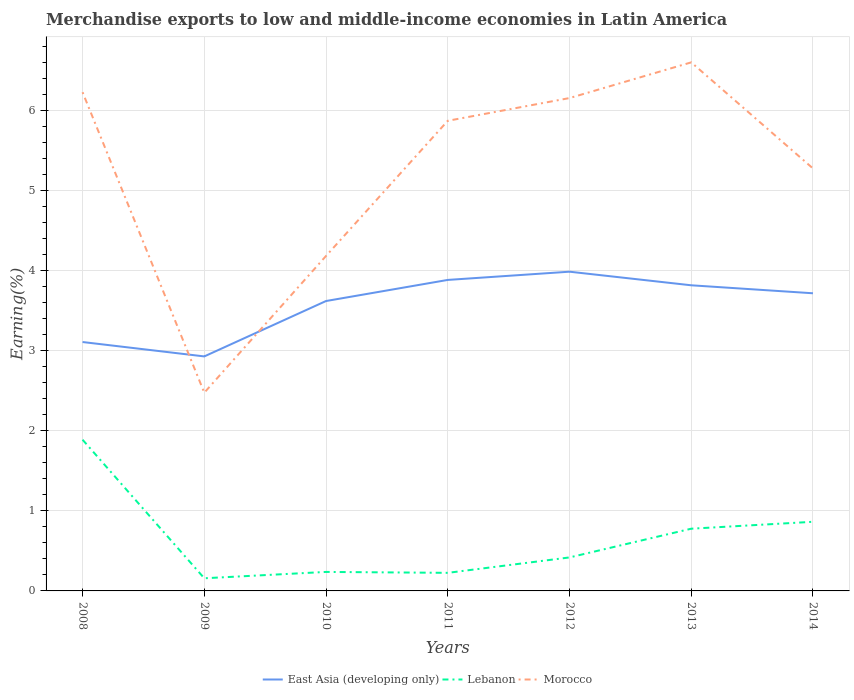Is the number of lines equal to the number of legend labels?
Your answer should be very brief. Yes. Across all years, what is the maximum percentage of amount earned from merchandise exports in Lebanon?
Ensure brevity in your answer.  0.16. In which year was the percentage of amount earned from merchandise exports in East Asia (developing only) maximum?
Your answer should be very brief. 2009. What is the total percentage of amount earned from merchandise exports in Morocco in the graph?
Offer a terse response. -1.09. What is the difference between the highest and the second highest percentage of amount earned from merchandise exports in Morocco?
Ensure brevity in your answer.  4.12. What is the difference between the highest and the lowest percentage of amount earned from merchandise exports in Lebanon?
Provide a succinct answer. 3. How many years are there in the graph?
Offer a very short reply. 7. What is the difference between two consecutive major ticks on the Y-axis?
Offer a terse response. 1. Does the graph contain grids?
Your response must be concise. Yes. Where does the legend appear in the graph?
Provide a short and direct response. Bottom center. How are the legend labels stacked?
Your answer should be compact. Horizontal. What is the title of the graph?
Offer a very short reply. Merchandise exports to low and middle-income economies in Latin America. Does "Latvia" appear as one of the legend labels in the graph?
Provide a short and direct response. No. What is the label or title of the Y-axis?
Your answer should be very brief. Earning(%). What is the Earning(%) in East Asia (developing only) in 2008?
Offer a terse response. 3.11. What is the Earning(%) of Lebanon in 2008?
Provide a succinct answer. 1.89. What is the Earning(%) of Morocco in 2008?
Provide a short and direct response. 6.23. What is the Earning(%) of East Asia (developing only) in 2009?
Offer a terse response. 2.93. What is the Earning(%) in Lebanon in 2009?
Make the answer very short. 0.16. What is the Earning(%) of Morocco in 2009?
Keep it short and to the point. 2.48. What is the Earning(%) in East Asia (developing only) in 2010?
Make the answer very short. 3.62. What is the Earning(%) in Lebanon in 2010?
Offer a terse response. 0.24. What is the Earning(%) in Morocco in 2010?
Your answer should be compact. 4.18. What is the Earning(%) of East Asia (developing only) in 2011?
Your answer should be very brief. 3.88. What is the Earning(%) in Lebanon in 2011?
Offer a very short reply. 0.23. What is the Earning(%) of Morocco in 2011?
Provide a short and direct response. 5.87. What is the Earning(%) of East Asia (developing only) in 2012?
Your response must be concise. 3.99. What is the Earning(%) in Lebanon in 2012?
Keep it short and to the point. 0.42. What is the Earning(%) in Morocco in 2012?
Provide a succinct answer. 6.15. What is the Earning(%) of East Asia (developing only) in 2013?
Ensure brevity in your answer.  3.82. What is the Earning(%) of Lebanon in 2013?
Offer a very short reply. 0.78. What is the Earning(%) in Morocco in 2013?
Provide a short and direct response. 6.6. What is the Earning(%) of East Asia (developing only) in 2014?
Your response must be concise. 3.72. What is the Earning(%) of Lebanon in 2014?
Ensure brevity in your answer.  0.86. What is the Earning(%) of Morocco in 2014?
Your answer should be very brief. 5.27. Across all years, what is the maximum Earning(%) of East Asia (developing only)?
Your answer should be compact. 3.99. Across all years, what is the maximum Earning(%) in Lebanon?
Provide a succinct answer. 1.89. Across all years, what is the maximum Earning(%) of Morocco?
Make the answer very short. 6.6. Across all years, what is the minimum Earning(%) in East Asia (developing only)?
Give a very brief answer. 2.93. Across all years, what is the minimum Earning(%) of Lebanon?
Provide a short and direct response. 0.16. Across all years, what is the minimum Earning(%) of Morocco?
Ensure brevity in your answer.  2.48. What is the total Earning(%) in East Asia (developing only) in the graph?
Give a very brief answer. 25.06. What is the total Earning(%) of Lebanon in the graph?
Offer a very short reply. 4.57. What is the total Earning(%) of Morocco in the graph?
Provide a short and direct response. 36.78. What is the difference between the Earning(%) in East Asia (developing only) in 2008 and that in 2009?
Keep it short and to the point. 0.18. What is the difference between the Earning(%) of Lebanon in 2008 and that in 2009?
Your answer should be very brief. 1.73. What is the difference between the Earning(%) in Morocco in 2008 and that in 2009?
Your answer should be compact. 3.75. What is the difference between the Earning(%) in East Asia (developing only) in 2008 and that in 2010?
Keep it short and to the point. -0.51. What is the difference between the Earning(%) of Lebanon in 2008 and that in 2010?
Offer a terse response. 1.65. What is the difference between the Earning(%) of Morocco in 2008 and that in 2010?
Offer a terse response. 2.04. What is the difference between the Earning(%) of East Asia (developing only) in 2008 and that in 2011?
Your response must be concise. -0.78. What is the difference between the Earning(%) of Lebanon in 2008 and that in 2011?
Offer a very short reply. 1.66. What is the difference between the Earning(%) in Morocco in 2008 and that in 2011?
Your answer should be very brief. 0.36. What is the difference between the Earning(%) in East Asia (developing only) in 2008 and that in 2012?
Ensure brevity in your answer.  -0.88. What is the difference between the Earning(%) of Lebanon in 2008 and that in 2012?
Your answer should be very brief. 1.47. What is the difference between the Earning(%) in Morocco in 2008 and that in 2012?
Give a very brief answer. 0.07. What is the difference between the Earning(%) in East Asia (developing only) in 2008 and that in 2013?
Make the answer very short. -0.71. What is the difference between the Earning(%) of Lebanon in 2008 and that in 2013?
Provide a short and direct response. 1.11. What is the difference between the Earning(%) in Morocco in 2008 and that in 2013?
Provide a short and direct response. -0.37. What is the difference between the Earning(%) in East Asia (developing only) in 2008 and that in 2014?
Keep it short and to the point. -0.61. What is the difference between the Earning(%) in Lebanon in 2008 and that in 2014?
Provide a short and direct response. 1.02. What is the difference between the Earning(%) of East Asia (developing only) in 2009 and that in 2010?
Keep it short and to the point. -0.69. What is the difference between the Earning(%) in Lebanon in 2009 and that in 2010?
Offer a very short reply. -0.08. What is the difference between the Earning(%) in Morocco in 2009 and that in 2010?
Keep it short and to the point. -1.71. What is the difference between the Earning(%) in East Asia (developing only) in 2009 and that in 2011?
Your answer should be compact. -0.95. What is the difference between the Earning(%) in Lebanon in 2009 and that in 2011?
Your answer should be very brief. -0.07. What is the difference between the Earning(%) of Morocco in 2009 and that in 2011?
Your response must be concise. -3.39. What is the difference between the Earning(%) of East Asia (developing only) in 2009 and that in 2012?
Your response must be concise. -1.06. What is the difference between the Earning(%) in Lebanon in 2009 and that in 2012?
Offer a very short reply. -0.26. What is the difference between the Earning(%) in Morocco in 2009 and that in 2012?
Offer a very short reply. -3.68. What is the difference between the Earning(%) in East Asia (developing only) in 2009 and that in 2013?
Ensure brevity in your answer.  -0.89. What is the difference between the Earning(%) in Lebanon in 2009 and that in 2013?
Offer a very short reply. -0.62. What is the difference between the Earning(%) in Morocco in 2009 and that in 2013?
Give a very brief answer. -4.12. What is the difference between the Earning(%) of East Asia (developing only) in 2009 and that in 2014?
Make the answer very short. -0.79. What is the difference between the Earning(%) of Lebanon in 2009 and that in 2014?
Ensure brevity in your answer.  -0.71. What is the difference between the Earning(%) of Morocco in 2009 and that in 2014?
Your response must be concise. -2.8. What is the difference between the Earning(%) in East Asia (developing only) in 2010 and that in 2011?
Your response must be concise. -0.26. What is the difference between the Earning(%) in Lebanon in 2010 and that in 2011?
Your answer should be compact. 0.01. What is the difference between the Earning(%) of Morocco in 2010 and that in 2011?
Give a very brief answer. -1.69. What is the difference between the Earning(%) of East Asia (developing only) in 2010 and that in 2012?
Ensure brevity in your answer.  -0.37. What is the difference between the Earning(%) of Lebanon in 2010 and that in 2012?
Your answer should be very brief. -0.18. What is the difference between the Earning(%) of Morocco in 2010 and that in 2012?
Your response must be concise. -1.97. What is the difference between the Earning(%) in East Asia (developing only) in 2010 and that in 2013?
Your answer should be compact. -0.2. What is the difference between the Earning(%) of Lebanon in 2010 and that in 2013?
Your answer should be compact. -0.54. What is the difference between the Earning(%) in Morocco in 2010 and that in 2013?
Your answer should be very brief. -2.42. What is the difference between the Earning(%) of East Asia (developing only) in 2010 and that in 2014?
Your answer should be very brief. -0.1. What is the difference between the Earning(%) in Lebanon in 2010 and that in 2014?
Your answer should be very brief. -0.63. What is the difference between the Earning(%) of Morocco in 2010 and that in 2014?
Offer a very short reply. -1.09. What is the difference between the Earning(%) in East Asia (developing only) in 2011 and that in 2012?
Offer a very short reply. -0.1. What is the difference between the Earning(%) of Lebanon in 2011 and that in 2012?
Your response must be concise. -0.19. What is the difference between the Earning(%) in Morocco in 2011 and that in 2012?
Your answer should be very brief. -0.28. What is the difference between the Earning(%) in East Asia (developing only) in 2011 and that in 2013?
Provide a short and direct response. 0.07. What is the difference between the Earning(%) in Lebanon in 2011 and that in 2013?
Give a very brief answer. -0.55. What is the difference between the Earning(%) in Morocco in 2011 and that in 2013?
Your answer should be compact. -0.73. What is the difference between the Earning(%) of East Asia (developing only) in 2011 and that in 2014?
Provide a succinct answer. 0.17. What is the difference between the Earning(%) of Lebanon in 2011 and that in 2014?
Your answer should be very brief. -0.64. What is the difference between the Earning(%) of Morocco in 2011 and that in 2014?
Give a very brief answer. 0.6. What is the difference between the Earning(%) in East Asia (developing only) in 2012 and that in 2013?
Offer a very short reply. 0.17. What is the difference between the Earning(%) in Lebanon in 2012 and that in 2013?
Make the answer very short. -0.36. What is the difference between the Earning(%) in Morocco in 2012 and that in 2013?
Offer a terse response. -0.45. What is the difference between the Earning(%) of East Asia (developing only) in 2012 and that in 2014?
Keep it short and to the point. 0.27. What is the difference between the Earning(%) of Lebanon in 2012 and that in 2014?
Your answer should be very brief. -0.45. What is the difference between the Earning(%) in Morocco in 2012 and that in 2014?
Keep it short and to the point. 0.88. What is the difference between the Earning(%) in East Asia (developing only) in 2013 and that in 2014?
Make the answer very short. 0.1. What is the difference between the Earning(%) in Lebanon in 2013 and that in 2014?
Give a very brief answer. -0.09. What is the difference between the Earning(%) of Morocco in 2013 and that in 2014?
Offer a very short reply. 1.32. What is the difference between the Earning(%) of East Asia (developing only) in 2008 and the Earning(%) of Lebanon in 2009?
Ensure brevity in your answer.  2.95. What is the difference between the Earning(%) of East Asia (developing only) in 2008 and the Earning(%) of Morocco in 2009?
Your answer should be compact. 0.63. What is the difference between the Earning(%) of Lebanon in 2008 and the Earning(%) of Morocco in 2009?
Provide a succinct answer. -0.59. What is the difference between the Earning(%) in East Asia (developing only) in 2008 and the Earning(%) in Lebanon in 2010?
Offer a terse response. 2.87. What is the difference between the Earning(%) of East Asia (developing only) in 2008 and the Earning(%) of Morocco in 2010?
Ensure brevity in your answer.  -1.07. What is the difference between the Earning(%) in Lebanon in 2008 and the Earning(%) in Morocco in 2010?
Keep it short and to the point. -2.29. What is the difference between the Earning(%) of East Asia (developing only) in 2008 and the Earning(%) of Lebanon in 2011?
Offer a terse response. 2.88. What is the difference between the Earning(%) of East Asia (developing only) in 2008 and the Earning(%) of Morocco in 2011?
Provide a short and direct response. -2.76. What is the difference between the Earning(%) in Lebanon in 2008 and the Earning(%) in Morocco in 2011?
Ensure brevity in your answer.  -3.98. What is the difference between the Earning(%) of East Asia (developing only) in 2008 and the Earning(%) of Lebanon in 2012?
Make the answer very short. 2.69. What is the difference between the Earning(%) in East Asia (developing only) in 2008 and the Earning(%) in Morocco in 2012?
Provide a short and direct response. -3.05. What is the difference between the Earning(%) of Lebanon in 2008 and the Earning(%) of Morocco in 2012?
Make the answer very short. -4.27. What is the difference between the Earning(%) of East Asia (developing only) in 2008 and the Earning(%) of Lebanon in 2013?
Your answer should be very brief. 2.33. What is the difference between the Earning(%) in East Asia (developing only) in 2008 and the Earning(%) in Morocco in 2013?
Provide a short and direct response. -3.49. What is the difference between the Earning(%) of Lebanon in 2008 and the Earning(%) of Morocco in 2013?
Keep it short and to the point. -4.71. What is the difference between the Earning(%) in East Asia (developing only) in 2008 and the Earning(%) in Lebanon in 2014?
Offer a terse response. 2.24. What is the difference between the Earning(%) of East Asia (developing only) in 2008 and the Earning(%) of Morocco in 2014?
Ensure brevity in your answer.  -2.17. What is the difference between the Earning(%) of Lebanon in 2008 and the Earning(%) of Morocco in 2014?
Your answer should be very brief. -3.39. What is the difference between the Earning(%) in East Asia (developing only) in 2009 and the Earning(%) in Lebanon in 2010?
Provide a succinct answer. 2.69. What is the difference between the Earning(%) in East Asia (developing only) in 2009 and the Earning(%) in Morocco in 2010?
Ensure brevity in your answer.  -1.25. What is the difference between the Earning(%) of Lebanon in 2009 and the Earning(%) of Morocco in 2010?
Give a very brief answer. -4.02. What is the difference between the Earning(%) in East Asia (developing only) in 2009 and the Earning(%) in Lebanon in 2011?
Offer a terse response. 2.7. What is the difference between the Earning(%) in East Asia (developing only) in 2009 and the Earning(%) in Morocco in 2011?
Provide a succinct answer. -2.94. What is the difference between the Earning(%) of Lebanon in 2009 and the Earning(%) of Morocco in 2011?
Your answer should be compact. -5.71. What is the difference between the Earning(%) of East Asia (developing only) in 2009 and the Earning(%) of Lebanon in 2012?
Make the answer very short. 2.51. What is the difference between the Earning(%) of East Asia (developing only) in 2009 and the Earning(%) of Morocco in 2012?
Your answer should be compact. -3.23. What is the difference between the Earning(%) of Lebanon in 2009 and the Earning(%) of Morocco in 2012?
Offer a very short reply. -6. What is the difference between the Earning(%) in East Asia (developing only) in 2009 and the Earning(%) in Lebanon in 2013?
Offer a terse response. 2.15. What is the difference between the Earning(%) in East Asia (developing only) in 2009 and the Earning(%) in Morocco in 2013?
Ensure brevity in your answer.  -3.67. What is the difference between the Earning(%) of Lebanon in 2009 and the Earning(%) of Morocco in 2013?
Provide a succinct answer. -6.44. What is the difference between the Earning(%) in East Asia (developing only) in 2009 and the Earning(%) in Lebanon in 2014?
Your response must be concise. 2.06. What is the difference between the Earning(%) of East Asia (developing only) in 2009 and the Earning(%) of Morocco in 2014?
Offer a very short reply. -2.35. What is the difference between the Earning(%) of Lebanon in 2009 and the Earning(%) of Morocco in 2014?
Provide a short and direct response. -5.12. What is the difference between the Earning(%) of East Asia (developing only) in 2010 and the Earning(%) of Lebanon in 2011?
Offer a terse response. 3.39. What is the difference between the Earning(%) of East Asia (developing only) in 2010 and the Earning(%) of Morocco in 2011?
Your answer should be very brief. -2.25. What is the difference between the Earning(%) in Lebanon in 2010 and the Earning(%) in Morocco in 2011?
Provide a succinct answer. -5.63. What is the difference between the Earning(%) in East Asia (developing only) in 2010 and the Earning(%) in Lebanon in 2012?
Ensure brevity in your answer.  3.2. What is the difference between the Earning(%) in East Asia (developing only) in 2010 and the Earning(%) in Morocco in 2012?
Ensure brevity in your answer.  -2.53. What is the difference between the Earning(%) in Lebanon in 2010 and the Earning(%) in Morocco in 2012?
Offer a terse response. -5.92. What is the difference between the Earning(%) of East Asia (developing only) in 2010 and the Earning(%) of Lebanon in 2013?
Ensure brevity in your answer.  2.84. What is the difference between the Earning(%) in East Asia (developing only) in 2010 and the Earning(%) in Morocco in 2013?
Your answer should be compact. -2.98. What is the difference between the Earning(%) in Lebanon in 2010 and the Earning(%) in Morocco in 2013?
Give a very brief answer. -6.36. What is the difference between the Earning(%) of East Asia (developing only) in 2010 and the Earning(%) of Lebanon in 2014?
Your answer should be very brief. 2.76. What is the difference between the Earning(%) in East Asia (developing only) in 2010 and the Earning(%) in Morocco in 2014?
Offer a very short reply. -1.66. What is the difference between the Earning(%) of Lebanon in 2010 and the Earning(%) of Morocco in 2014?
Keep it short and to the point. -5.04. What is the difference between the Earning(%) in East Asia (developing only) in 2011 and the Earning(%) in Lebanon in 2012?
Provide a short and direct response. 3.46. What is the difference between the Earning(%) of East Asia (developing only) in 2011 and the Earning(%) of Morocco in 2012?
Make the answer very short. -2.27. What is the difference between the Earning(%) of Lebanon in 2011 and the Earning(%) of Morocco in 2012?
Offer a terse response. -5.93. What is the difference between the Earning(%) in East Asia (developing only) in 2011 and the Earning(%) in Lebanon in 2013?
Keep it short and to the point. 3.11. What is the difference between the Earning(%) of East Asia (developing only) in 2011 and the Earning(%) of Morocco in 2013?
Keep it short and to the point. -2.72. What is the difference between the Earning(%) in Lebanon in 2011 and the Earning(%) in Morocco in 2013?
Provide a short and direct response. -6.37. What is the difference between the Earning(%) in East Asia (developing only) in 2011 and the Earning(%) in Lebanon in 2014?
Your answer should be compact. 3.02. What is the difference between the Earning(%) in East Asia (developing only) in 2011 and the Earning(%) in Morocco in 2014?
Your answer should be very brief. -1.39. What is the difference between the Earning(%) in Lebanon in 2011 and the Earning(%) in Morocco in 2014?
Offer a very short reply. -5.05. What is the difference between the Earning(%) of East Asia (developing only) in 2012 and the Earning(%) of Lebanon in 2013?
Your answer should be very brief. 3.21. What is the difference between the Earning(%) of East Asia (developing only) in 2012 and the Earning(%) of Morocco in 2013?
Give a very brief answer. -2.61. What is the difference between the Earning(%) of Lebanon in 2012 and the Earning(%) of Morocco in 2013?
Ensure brevity in your answer.  -6.18. What is the difference between the Earning(%) in East Asia (developing only) in 2012 and the Earning(%) in Lebanon in 2014?
Give a very brief answer. 3.12. What is the difference between the Earning(%) in East Asia (developing only) in 2012 and the Earning(%) in Morocco in 2014?
Your answer should be compact. -1.29. What is the difference between the Earning(%) in Lebanon in 2012 and the Earning(%) in Morocco in 2014?
Your response must be concise. -4.86. What is the difference between the Earning(%) of East Asia (developing only) in 2013 and the Earning(%) of Lebanon in 2014?
Keep it short and to the point. 2.95. What is the difference between the Earning(%) of East Asia (developing only) in 2013 and the Earning(%) of Morocco in 2014?
Provide a short and direct response. -1.46. What is the difference between the Earning(%) in Lebanon in 2013 and the Earning(%) in Morocco in 2014?
Ensure brevity in your answer.  -4.5. What is the average Earning(%) of East Asia (developing only) per year?
Provide a short and direct response. 3.58. What is the average Earning(%) of Lebanon per year?
Ensure brevity in your answer.  0.65. What is the average Earning(%) in Morocco per year?
Make the answer very short. 5.25. In the year 2008, what is the difference between the Earning(%) of East Asia (developing only) and Earning(%) of Lebanon?
Your answer should be very brief. 1.22. In the year 2008, what is the difference between the Earning(%) of East Asia (developing only) and Earning(%) of Morocco?
Offer a very short reply. -3.12. In the year 2008, what is the difference between the Earning(%) in Lebanon and Earning(%) in Morocco?
Make the answer very short. -4.34. In the year 2009, what is the difference between the Earning(%) of East Asia (developing only) and Earning(%) of Lebanon?
Your response must be concise. 2.77. In the year 2009, what is the difference between the Earning(%) of East Asia (developing only) and Earning(%) of Morocco?
Give a very brief answer. 0.45. In the year 2009, what is the difference between the Earning(%) of Lebanon and Earning(%) of Morocco?
Provide a succinct answer. -2.32. In the year 2010, what is the difference between the Earning(%) of East Asia (developing only) and Earning(%) of Lebanon?
Your answer should be compact. 3.38. In the year 2010, what is the difference between the Earning(%) in East Asia (developing only) and Earning(%) in Morocco?
Your answer should be very brief. -0.56. In the year 2010, what is the difference between the Earning(%) of Lebanon and Earning(%) of Morocco?
Provide a short and direct response. -3.95. In the year 2011, what is the difference between the Earning(%) in East Asia (developing only) and Earning(%) in Lebanon?
Your response must be concise. 3.66. In the year 2011, what is the difference between the Earning(%) in East Asia (developing only) and Earning(%) in Morocco?
Provide a short and direct response. -1.99. In the year 2011, what is the difference between the Earning(%) in Lebanon and Earning(%) in Morocco?
Offer a very short reply. -5.64. In the year 2012, what is the difference between the Earning(%) of East Asia (developing only) and Earning(%) of Lebanon?
Offer a terse response. 3.57. In the year 2012, what is the difference between the Earning(%) in East Asia (developing only) and Earning(%) in Morocco?
Provide a succinct answer. -2.17. In the year 2012, what is the difference between the Earning(%) in Lebanon and Earning(%) in Morocco?
Ensure brevity in your answer.  -5.74. In the year 2013, what is the difference between the Earning(%) of East Asia (developing only) and Earning(%) of Lebanon?
Make the answer very short. 3.04. In the year 2013, what is the difference between the Earning(%) of East Asia (developing only) and Earning(%) of Morocco?
Your response must be concise. -2.78. In the year 2013, what is the difference between the Earning(%) of Lebanon and Earning(%) of Morocco?
Your answer should be compact. -5.82. In the year 2014, what is the difference between the Earning(%) in East Asia (developing only) and Earning(%) in Lebanon?
Your answer should be compact. 2.85. In the year 2014, what is the difference between the Earning(%) of East Asia (developing only) and Earning(%) of Morocco?
Offer a very short reply. -1.56. In the year 2014, what is the difference between the Earning(%) of Lebanon and Earning(%) of Morocco?
Provide a short and direct response. -4.41. What is the ratio of the Earning(%) of East Asia (developing only) in 2008 to that in 2009?
Offer a very short reply. 1.06. What is the ratio of the Earning(%) of Lebanon in 2008 to that in 2009?
Give a very brief answer. 11.95. What is the ratio of the Earning(%) in Morocco in 2008 to that in 2009?
Provide a succinct answer. 2.52. What is the ratio of the Earning(%) in East Asia (developing only) in 2008 to that in 2010?
Offer a terse response. 0.86. What is the ratio of the Earning(%) in Lebanon in 2008 to that in 2010?
Make the answer very short. 7.96. What is the ratio of the Earning(%) in Morocco in 2008 to that in 2010?
Offer a terse response. 1.49. What is the ratio of the Earning(%) of East Asia (developing only) in 2008 to that in 2011?
Your answer should be very brief. 0.8. What is the ratio of the Earning(%) in Lebanon in 2008 to that in 2011?
Provide a succinct answer. 8.36. What is the ratio of the Earning(%) of Morocco in 2008 to that in 2011?
Offer a terse response. 1.06. What is the ratio of the Earning(%) in East Asia (developing only) in 2008 to that in 2012?
Ensure brevity in your answer.  0.78. What is the ratio of the Earning(%) in Lebanon in 2008 to that in 2012?
Your answer should be compact. 4.51. What is the ratio of the Earning(%) in Morocco in 2008 to that in 2012?
Your answer should be very brief. 1.01. What is the ratio of the Earning(%) of East Asia (developing only) in 2008 to that in 2013?
Your response must be concise. 0.81. What is the ratio of the Earning(%) of Lebanon in 2008 to that in 2013?
Your answer should be compact. 2.43. What is the ratio of the Earning(%) of Morocco in 2008 to that in 2013?
Provide a succinct answer. 0.94. What is the ratio of the Earning(%) of East Asia (developing only) in 2008 to that in 2014?
Make the answer very short. 0.84. What is the ratio of the Earning(%) of Lebanon in 2008 to that in 2014?
Give a very brief answer. 2.19. What is the ratio of the Earning(%) of Morocco in 2008 to that in 2014?
Provide a short and direct response. 1.18. What is the ratio of the Earning(%) of East Asia (developing only) in 2009 to that in 2010?
Provide a short and direct response. 0.81. What is the ratio of the Earning(%) of Lebanon in 2009 to that in 2010?
Make the answer very short. 0.67. What is the ratio of the Earning(%) of Morocco in 2009 to that in 2010?
Offer a terse response. 0.59. What is the ratio of the Earning(%) of East Asia (developing only) in 2009 to that in 2011?
Ensure brevity in your answer.  0.75. What is the ratio of the Earning(%) of Lebanon in 2009 to that in 2011?
Give a very brief answer. 0.7. What is the ratio of the Earning(%) in Morocco in 2009 to that in 2011?
Offer a terse response. 0.42. What is the ratio of the Earning(%) of East Asia (developing only) in 2009 to that in 2012?
Ensure brevity in your answer.  0.73. What is the ratio of the Earning(%) of Lebanon in 2009 to that in 2012?
Provide a short and direct response. 0.38. What is the ratio of the Earning(%) in Morocco in 2009 to that in 2012?
Offer a terse response. 0.4. What is the ratio of the Earning(%) of East Asia (developing only) in 2009 to that in 2013?
Make the answer very short. 0.77. What is the ratio of the Earning(%) of Lebanon in 2009 to that in 2013?
Offer a terse response. 0.2. What is the ratio of the Earning(%) of Morocco in 2009 to that in 2013?
Keep it short and to the point. 0.38. What is the ratio of the Earning(%) in East Asia (developing only) in 2009 to that in 2014?
Keep it short and to the point. 0.79. What is the ratio of the Earning(%) in Lebanon in 2009 to that in 2014?
Your response must be concise. 0.18. What is the ratio of the Earning(%) of Morocco in 2009 to that in 2014?
Offer a terse response. 0.47. What is the ratio of the Earning(%) of East Asia (developing only) in 2010 to that in 2011?
Make the answer very short. 0.93. What is the ratio of the Earning(%) in Lebanon in 2010 to that in 2011?
Offer a very short reply. 1.05. What is the ratio of the Earning(%) of Morocco in 2010 to that in 2011?
Your answer should be very brief. 0.71. What is the ratio of the Earning(%) of East Asia (developing only) in 2010 to that in 2012?
Your answer should be compact. 0.91. What is the ratio of the Earning(%) in Lebanon in 2010 to that in 2012?
Keep it short and to the point. 0.57. What is the ratio of the Earning(%) in Morocco in 2010 to that in 2012?
Provide a short and direct response. 0.68. What is the ratio of the Earning(%) of East Asia (developing only) in 2010 to that in 2013?
Give a very brief answer. 0.95. What is the ratio of the Earning(%) in Lebanon in 2010 to that in 2013?
Provide a succinct answer. 0.31. What is the ratio of the Earning(%) in Morocco in 2010 to that in 2013?
Make the answer very short. 0.63. What is the ratio of the Earning(%) of Lebanon in 2010 to that in 2014?
Your answer should be compact. 0.27. What is the ratio of the Earning(%) of Morocco in 2010 to that in 2014?
Keep it short and to the point. 0.79. What is the ratio of the Earning(%) in East Asia (developing only) in 2011 to that in 2012?
Make the answer very short. 0.97. What is the ratio of the Earning(%) of Lebanon in 2011 to that in 2012?
Provide a succinct answer. 0.54. What is the ratio of the Earning(%) of Morocco in 2011 to that in 2012?
Ensure brevity in your answer.  0.95. What is the ratio of the Earning(%) in East Asia (developing only) in 2011 to that in 2013?
Offer a terse response. 1.02. What is the ratio of the Earning(%) of Lebanon in 2011 to that in 2013?
Offer a terse response. 0.29. What is the ratio of the Earning(%) in Morocco in 2011 to that in 2013?
Your answer should be very brief. 0.89. What is the ratio of the Earning(%) of East Asia (developing only) in 2011 to that in 2014?
Offer a very short reply. 1.04. What is the ratio of the Earning(%) of Lebanon in 2011 to that in 2014?
Your answer should be very brief. 0.26. What is the ratio of the Earning(%) of Morocco in 2011 to that in 2014?
Your answer should be very brief. 1.11. What is the ratio of the Earning(%) of East Asia (developing only) in 2012 to that in 2013?
Make the answer very short. 1.04. What is the ratio of the Earning(%) in Lebanon in 2012 to that in 2013?
Keep it short and to the point. 0.54. What is the ratio of the Earning(%) in Morocco in 2012 to that in 2013?
Your answer should be compact. 0.93. What is the ratio of the Earning(%) of East Asia (developing only) in 2012 to that in 2014?
Offer a terse response. 1.07. What is the ratio of the Earning(%) of Lebanon in 2012 to that in 2014?
Keep it short and to the point. 0.48. What is the ratio of the Earning(%) in Morocco in 2012 to that in 2014?
Your response must be concise. 1.17. What is the ratio of the Earning(%) in East Asia (developing only) in 2013 to that in 2014?
Ensure brevity in your answer.  1.03. What is the ratio of the Earning(%) of Morocco in 2013 to that in 2014?
Keep it short and to the point. 1.25. What is the difference between the highest and the second highest Earning(%) of East Asia (developing only)?
Your answer should be very brief. 0.1. What is the difference between the highest and the second highest Earning(%) of Lebanon?
Ensure brevity in your answer.  1.02. What is the difference between the highest and the second highest Earning(%) in Morocco?
Your answer should be very brief. 0.37. What is the difference between the highest and the lowest Earning(%) in East Asia (developing only)?
Give a very brief answer. 1.06. What is the difference between the highest and the lowest Earning(%) of Lebanon?
Provide a succinct answer. 1.73. What is the difference between the highest and the lowest Earning(%) in Morocco?
Your answer should be compact. 4.12. 